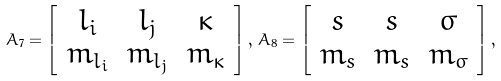<formula> <loc_0><loc_0><loc_500><loc_500>A _ { 7 } = \left [ \begin{array} { c c c } l _ { i } & l _ { j } & \kappa \\ m _ { l _ { i } } & m _ { l _ { j } } & m _ { \kappa } \end{array} \right ] , \, A _ { 8 } = \left [ \begin{array} { c c c } s & s & \sigma \\ m _ { s } & m _ { s } & m _ { \sigma } \end{array} \right ] ,</formula> 